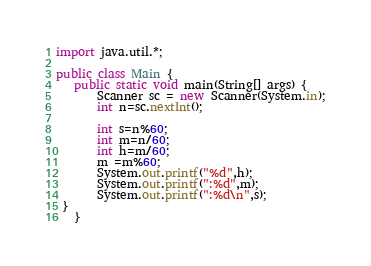Convert code to text. <code><loc_0><loc_0><loc_500><loc_500><_Java_>import java.util.*;

public class Main {
   public static void main(String[] args) {
       Scanner sc = new Scanner(System.in);
       int n=sc.nextInt();
       
       int s=n%60;
       int m=n/60;
       int h=m/60;
       m =m%60;
       System.out.printf("%d",h);
       System.out.printf(":%d",m);
       System.out.printf(":%d\n",s);
 }
   }</code> 